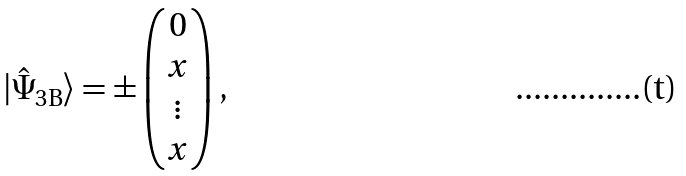<formula> <loc_0><loc_0><loc_500><loc_500>| \hat { \Psi } _ { 3 \text {B} } \rangle = \pm \begin{pmatrix} 0 \\ x \\ \vdots \\ x \end{pmatrix} ,</formula> 